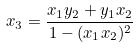<formula> <loc_0><loc_0><loc_500><loc_500>x _ { 3 } = \frac { x _ { 1 } y _ { 2 } + y _ { 1 } x _ { 2 } } { 1 - ( x _ { 1 } x _ { 2 } ) ^ { 2 } }</formula> 